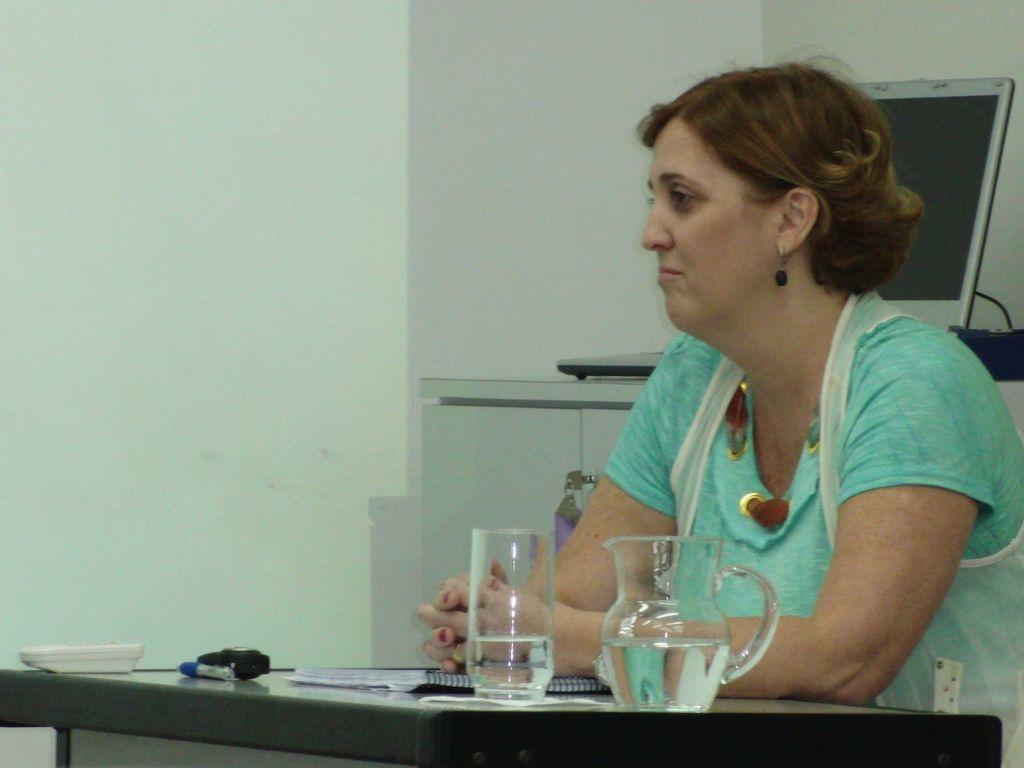Please provide a concise description of this image. In this picture we can see a glass, a jug, a book and a few things visible on the table. There is the liquid visible in a glass and in a jar. We can see a woman, a laptop and other objects. 